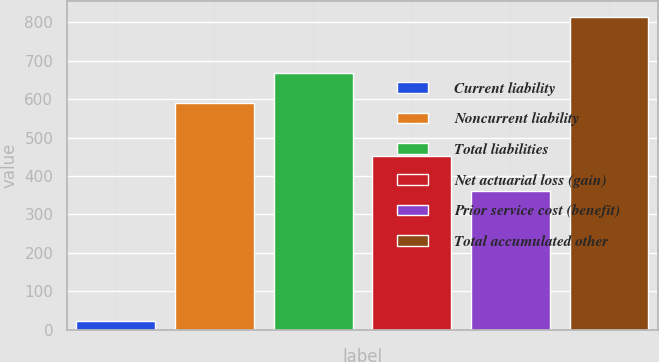Convert chart to OTSL. <chart><loc_0><loc_0><loc_500><loc_500><bar_chart><fcel>Current liability<fcel>Noncurrent liability<fcel>Total liabilities<fcel>Net actuarial loss (gain)<fcel>Prior service cost (benefit)<fcel>Total accumulated other<nl><fcel>23<fcel>589<fcel>668.1<fcel>452<fcel>362<fcel>814<nl></chart> 